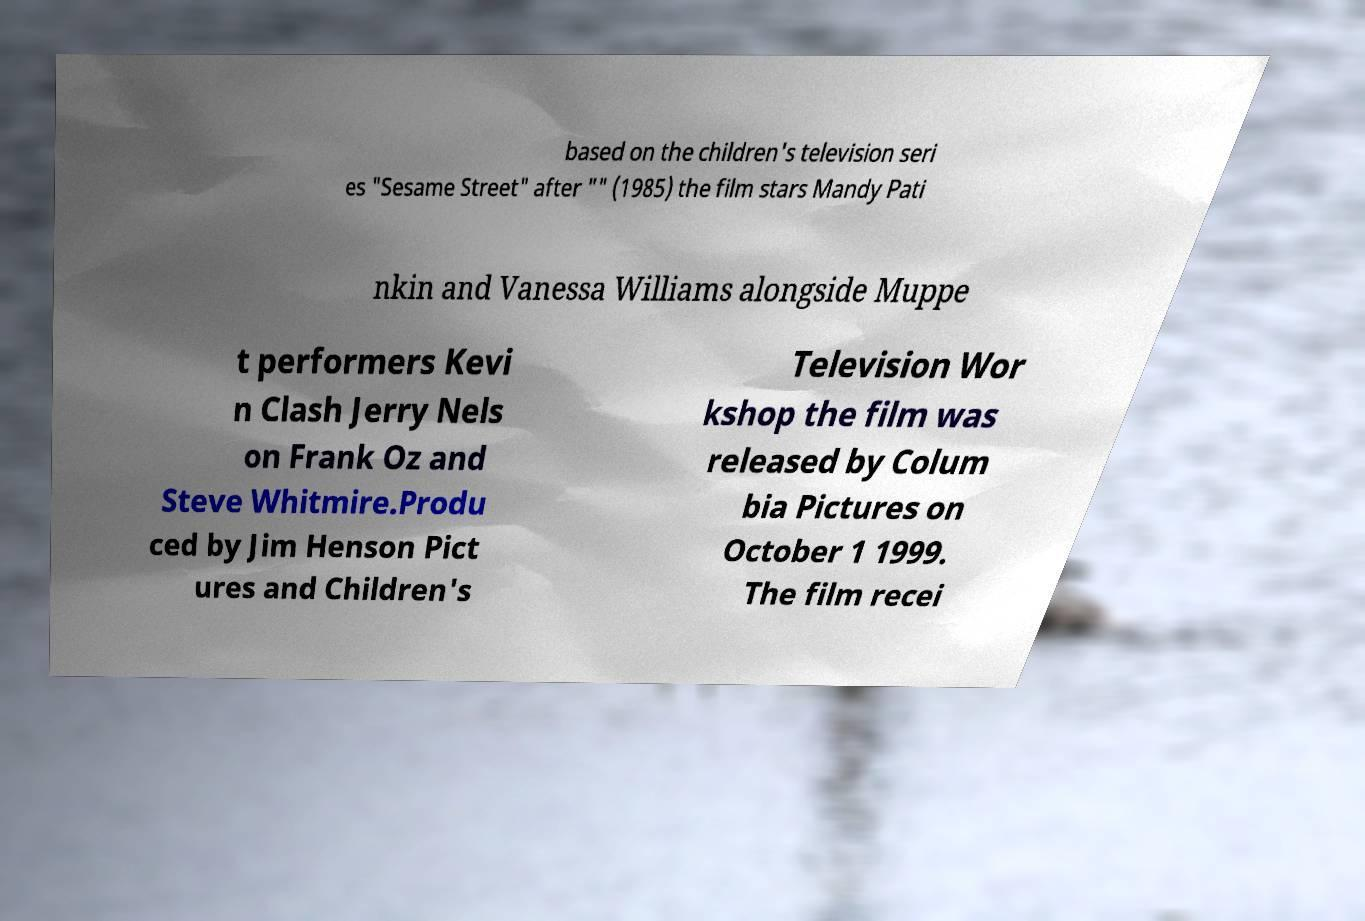Can you read and provide the text displayed in the image?This photo seems to have some interesting text. Can you extract and type it out for me? based on the children's television seri es "Sesame Street" after "" (1985) the film stars Mandy Pati nkin and Vanessa Williams alongside Muppe t performers Kevi n Clash Jerry Nels on Frank Oz and Steve Whitmire.Produ ced by Jim Henson Pict ures and Children's Television Wor kshop the film was released by Colum bia Pictures on October 1 1999. The film recei 